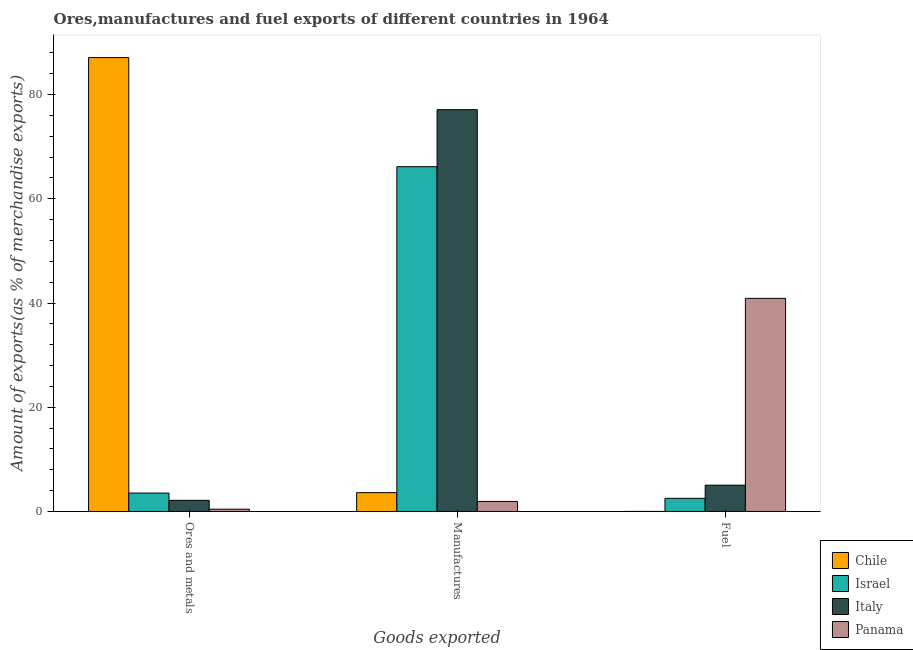How many groups of bars are there?
Your answer should be very brief. 3. Are the number of bars on each tick of the X-axis equal?
Your answer should be very brief. Yes. How many bars are there on the 3rd tick from the left?
Your answer should be compact. 4. What is the label of the 3rd group of bars from the left?
Keep it short and to the point. Fuel. What is the percentage of manufactures exports in Israel?
Provide a short and direct response. 66.16. Across all countries, what is the maximum percentage of manufactures exports?
Provide a succinct answer. 77.1. Across all countries, what is the minimum percentage of fuel exports?
Offer a terse response. 0.01. In which country was the percentage of fuel exports maximum?
Your response must be concise. Panama. In which country was the percentage of manufactures exports minimum?
Make the answer very short. Panama. What is the total percentage of fuel exports in the graph?
Ensure brevity in your answer.  48.48. What is the difference between the percentage of manufactures exports in Italy and that in Israel?
Make the answer very short. 10.94. What is the difference between the percentage of fuel exports in Panama and the percentage of manufactures exports in Italy?
Your answer should be compact. -36.21. What is the average percentage of fuel exports per country?
Ensure brevity in your answer.  12.12. What is the difference between the percentage of manufactures exports and percentage of ores and metals exports in Chile?
Provide a succinct answer. -83.48. In how many countries, is the percentage of ores and metals exports greater than 8 %?
Your answer should be compact. 1. What is the ratio of the percentage of ores and metals exports in Chile to that in Italy?
Offer a very short reply. 40.66. What is the difference between the highest and the second highest percentage of ores and metals exports?
Your answer should be very brief. 83.56. What is the difference between the highest and the lowest percentage of manufactures exports?
Provide a short and direct response. 75.18. In how many countries, is the percentage of ores and metals exports greater than the average percentage of ores and metals exports taken over all countries?
Your response must be concise. 1. Is the sum of the percentage of fuel exports in Italy and Chile greater than the maximum percentage of ores and metals exports across all countries?
Give a very brief answer. No. What does the 3rd bar from the left in Fuel represents?
Provide a short and direct response. Italy. What does the 1st bar from the right in Ores and metals represents?
Offer a very short reply. Panama. How many bars are there?
Your answer should be compact. 12. Are the values on the major ticks of Y-axis written in scientific E-notation?
Offer a terse response. No. Does the graph contain any zero values?
Your answer should be compact. No. Does the graph contain grids?
Give a very brief answer. No. Where does the legend appear in the graph?
Your response must be concise. Bottom right. What is the title of the graph?
Offer a terse response. Ores,manufactures and fuel exports of different countries in 1964. Does "Middle income" appear as one of the legend labels in the graph?
Your answer should be very brief. No. What is the label or title of the X-axis?
Ensure brevity in your answer.  Goods exported. What is the label or title of the Y-axis?
Offer a terse response. Amount of exports(as % of merchandise exports). What is the Amount of exports(as % of merchandise exports) in Chile in Ores and metals?
Your answer should be compact. 87.1. What is the Amount of exports(as % of merchandise exports) in Israel in Ores and metals?
Offer a very short reply. 3.53. What is the Amount of exports(as % of merchandise exports) of Italy in Ores and metals?
Offer a very short reply. 2.14. What is the Amount of exports(as % of merchandise exports) in Panama in Ores and metals?
Provide a short and direct response. 0.44. What is the Amount of exports(as % of merchandise exports) in Chile in Manufactures?
Your answer should be very brief. 3.62. What is the Amount of exports(as % of merchandise exports) in Israel in Manufactures?
Your answer should be compact. 66.16. What is the Amount of exports(as % of merchandise exports) of Italy in Manufactures?
Ensure brevity in your answer.  77.1. What is the Amount of exports(as % of merchandise exports) of Panama in Manufactures?
Provide a succinct answer. 1.93. What is the Amount of exports(as % of merchandise exports) of Chile in Fuel?
Give a very brief answer. 0.01. What is the Amount of exports(as % of merchandise exports) of Israel in Fuel?
Offer a terse response. 2.53. What is the Amount of exports(as % of merchandise exports) of Italy in Fuel?
Offer a terse response. 5.05. What is the Amount of exports(as % of merchandise exports) in Panama in Fuel?
Your answer should be compact. 40.9. Across all Goods exported, what is the maximum Amount of exports(as % of merchandise exports) in Chile?
Provide a short and direct response. 87.1. Across all Goods exported, what is the maximum Amount of exports(as % of merchandise exports) of Israel?
Your answer should be very brief. 66.16. Across all Goods exported, what is the maximum Amount of exports(as % of merchandise exports) of Italy?
Offer a terse response. 77.1. Across all Goods exported, what is the maximum Amount of exports(as % of merchandise exports) of Panama?
Offer a terse response. 40.9. Across all Goods exported, what is the minimum Amount of exports(as % of merchandise exports) of Chile?
Keep it short and to the point. 0.01. Across all Goods exported, what is the minimum Amount of exports(as % of merchandise exports) of Israel?
Keep it short and to the point. 2.53. Across all Goods exported, what is the minimum Amount of exports(as % of merchandise exports) in Italy?
Your answer should be compact. 2.14. Across all Goods exported, what is the minimum Amount of exports(as % of merchandise exports) in Panama?
Your answer should be very brief. 0.44. What is the total Amount of exports(as % of merchandise exports) in Chile in the graph?
Your response must be concise. 90.72. What is the total Amount of exports(as % of merchandise exports) in Israel in the graph?
Your answer should be very brief. 72.22. What is the total Amount of exports(as % of merchandise exports) in Italy in the graph?
Give a very brief answer. 84.3. What is the total Amount of exports(as % of merchandise exports) of Panama in the graph?
Provide a short and direct response. 43.27. What is the difference between the Amount of exports(as % of merchandise exports) in Chile in Ores and metals and that in Manufactures?
Make the answer very short. 83.48. What is the difference between the Amount of exports(as % of merchandise exports) in Israel in Ores and metals and that in Manufactures?
Provide a short and direct response. -62.63. What is the difference between the Amount of exports(as % of merchandise exports) in Italy in Ores and metals and that in Manufactures?
Your answer should be compact. -74.96. What is the difference between the Amount of exports(as % of merchandise exports) of Panama in Ores and metals and that in Manufactures?
Offer a terse response. -1.48. What is the difference between the Amount of exports(as % of merchandise exports) in Chile in Ores and metals and that in Fuel?
Make the answer very short. 87.09. What is the difference between the Amount of exports(as % of merchandise exports) in Israel in Ores and metals and that in Fuel?
Keep it short and to the point. 1.01. What is the difference between the Amount of exports(as % of merchandise exports) of Italy in Ores and metals and that in Fuel?
Offer a very short reply. -2.91. What is the difference between the Amount of exports(as % of merchandise exports) in Panama in Ores and metals and that in Fuel?
Keep it short and to the point. -40.46. What is the difference between the Amount of exports(as % of merchandise exports) of Chile in Manufactures and that in Fuel?
Make the answer very short. 3.61. What is the difference between the Amount of exports(as % of merchandise exports) in Israel in Manufactures and that in Fuel?
Provide a short and direct response. 63.63. What is the difference between the Amount of exports(as % of merchandise exports) in Italy in Manufactures and that in Fuel?
Your answer should be very brief. 72.05. What is the difference between the Amount of exports(as % of merchandise exports) of Panama in Manufactures and that in Fuel?
Offer a terse response. -38.97. What is the difference between the Amount of exports(as % of merchandise exports) in Chile in Ores and metals and the Amount of exports(as % of merchandise exports) in Israel in Manufactures?
Your answer should be compact. 20.94. What is the difference between the Amount of exports(as % of merchandise exports) in Chile in Ores and metals and the Amount of exports(as % of merchandise exports) in Italy in Manufactures?
Provide a succinct answer. 9.99. What is the difference between the Amount of exports(as % of merchandise exports) of Chile in Ores and metals and the Amount of exports(as % of merchandise exports) of Panama in Manufactures?
Keep it short and to the point. 85.17. What is the difference between the Amount of exports(as % of merchandise exports) of Israel in Ores and metals and the Amount of exports(as % of merchandise exports) of Italy in Manufactures?
Offer a very short reply. -73.57. What is the difference between the Amount of exports(as % of merchandise exports) of Israel in Ores and metals and the Amount of exports(as % of merchandise exports) of Panama in Manufactures?
Provide a succinct answer. 1.61. What is the difference between the Amount of exports(as % of merchandise exports) in Italy in Ores and metals and the Amount of exports(as % of merchandise exports) in Panama in Manufactures?
Offer a terse response. 0.22. What is the difference between the Amount of exports(as % of merchandise exports) of Chile in Ores and metals and the Amount of exports(as % of merchandise exports) of Israel in Fuel?
Your response must be concise. 84.57. What is the difference between the Amount of exports(as % of merchandise exports) in Chile in Ores and metals and the Amount of exports(as % of merchandise exports) in Italy in Fuel?
Provide a short and direct response. 82.05. What is the difference between the Amount of exports(as % of merchandise exports) in Chile in Ores and metals and the Amount of exports(as % of merchandise exports) in Panama in Fuel?
Provide a succinct answer. 46.2. What is the difference between the Amount of exports(as % of merchandise exports) of Israel in Ores and metals and the Amount of exports(as % of merchandise exports) of Italy in Fuel?
Provide a succinct answer. -1.52. What is the difference between the Amount of exports(as % of merchandise exports) in Israel in Ores and metals and the Amount of exports(as % of merchandise exports) in Panama in Fuel?
Make the answer very short. -37.36. What is the difference between the Amount of exports(as % of merchandise exports) in Italy in Ores and metals and the Amount of exports(as % of merchandise exports) in Panama in Fuel?
Your answer should be compact. -38.76. What is the difference between the Amount of exports(as % of merchandise exports) in Chile in Manufactures and the Amount of exports(as % of merchandise exports) in Israel in Fuel?
Give a very brief answer. 1.09. What is the difference between the Amount of exports(as % of merchandise exports) of Chile in Manufactures and the Amount of exports(as % of merchandise exports) of Italy in Fuel?
Your answer should be very brief. -1.43. What is the difference between the Amount of exports(as % of merchandise exports) in Chile in Manufactures and the Amount of exports(as % of merchandise exports) in Panama in Fuel?
Your answer should be very brief. -37.28. What is the difference between the Amount of exports(as % of merchandise exports) in Israel in Manufactures and the Amount of exports(as % of merchandise exports) in Italy in Fuel?
Keep it short and to the point. 61.11. What is the difference between the Amount of exports(as % of merchandise exports) in Israel in Manufactures and the Amount of exports(as % of merchandise exports) in Panama in Fuel?
Ensure brevity in your answer.  25.26. What is the difference between the Amount of exports(as % of merchandise exports) in Italy in Manufactures and the Amount of exports(as % of merchandise exports) in Panama in Fuel?
Offer a terse response. 36.21. What is the average Amount of exports(as % of merchandise exports) of Chile per Goods exported?
Provide a succinct answer. 30.24. What is the average Amount of exports(as % of merchandise exports) in Israel per Goods exported?
Provide a succinct answer. 24.07. What is the average Amount of exports(as % of merchandise exports) in Italy per Goods exported?
Ensure brevity in your answer.  28.1. What is the average Amount of exports(as % of merchandise exports) of Panama per Goods exported?
Ensure brevity in your answer.  14.42. What is the difference between the Amount of exports(as % of merchandise exports) of Chile and Amount of exports(as % of merchandise exports) of Israel in Ores and metals?
Make the answer very short. 83.56. What is the difference between the Amount of exports(as % of merchandise exports) in Chile and Amount of exports(as % of merchandise exports) in Italy in Ores and metals?
Your answer should be very brief. 84.96. What is the difference between the Amount of exports(as % of merchandise exports) of Chile and Amount of exports(as % of merchandise exports) of Panama in Ores and metals?
Provide a succinct answer. 86.66. What is the difference between the Amount of exports(as % of merchandise exports) in Israel and Amount of exports(as % of merchandise exports) in Italy in Ores and metals?
Offer a terse response. 1.39. What is the difference between the Amount of exports(as % of merchandise exports) in Israel and Amount of exports(as % of merchandise exports) in Panama in Ores and metals?
Provide a succinct answer. 3.09. What is the difference between the Amount of exports(as % of merchandise exports) of Italy and Amount of exports(as % of merchandise exports) of Panama in Ores and metals?
Your answer should be very brief. 1.7. What is the difference between the Amount of exports(as % of merchandise exports) of Chile and Amount of exports(as % of merchandise exports) of Israel in Manufactures?
Offer a very short reply. -62.54. What is the difference between the Amount of exports(as % of merchandise exports) of Chile and Amount of exports(as % of merchandise exports) of Italy in Manufactures?
Make the answer very short. -73.49. What is the difference between the Amount of exports(as % of merchandise exports) of Chile and Amount of exports(as % of merchandise exports) of Panama in Manufactures?
Make the answer very short. 1.69. What is the difference between the Amount of exports(as % of merchandise exports) of Israel and Amount of exports(as % of merchandise exports) of Italy in Manufactures?
Your answer should be compact. -10.94. What is the difference between the Amount of exports(as % of merchandise exports) in Israel and Amount of exports(as % of merchandise exports) in Panama in Manufactures?
Ensure brevity in your answer.  64.23. What is the difference between the Amount of exports(as % of merchandise exports) of Italy and Amount of exports(as % of merchandise exports) of Panama in Manufactures?
Your answer should be very brief. 75.18. What is the difference between the Amount of exports(as % of merchandise exports) in Chile and Amount of exports(as % of merchandise exports) in Israel in Fuel?
Your response must be concise. -2.52. What is the difference between the Amount of exports(as % of merchandise exports) in Chile and Amount of exports(as % of merchandise exports) in Italy in Fuel?
Make the answer very short. -5.04. What is the difference between the Amount of exports(as % of merchandise exports) in Chile and Amount of exports(as % of merchandise exports) in Panama in Fuel?
Your answer should be compact. -40.89. What is the difference between the Amount of exports(as % of merchandise exports) in Israel and Amount of exports(as % of merchandise exports) in Italy in Fuel?
Ensure brevity in your answer.  -2.53. What is the difference between the Amount of exports(as % of merchandise exports) in Israel and Amount of exports(as % of merchandise exports) in Panama in Fuel?
Your answer should be compact. -38.37. What is the difference between the Amount of exports(as % of merchandise exports) of Italy and Amount of exports(as % of merchandise exports) of Panama in Fuel?
Your answer should be compact. -35.85. What is the ratio of the Amount of exports(as % of merchandise exports) in Chile in Ores and metals to that in Manufactures?
Make the answer very short. 24.07. What is the ratio of the Amount of exports(as % of merchandise exports) of Israel in Ores and metals to that in Manufactures?
Offer a very short reply. 0.05. What is the ratio of the Amount of exports(as % of merchandise exports) in Italy in Ores and metals to that in Manufactures?
Give a very brief answer. 0.03. What is the ratio of the Amount of exports(as % of merchandise exports) of Panama in Ores and metals to that in Manufactures?
Your answer should be very brief. 0.23. What is the ratio of the Amount of exports(as % of merchandise exports) in Chile in Ores and metals to that in Fuel?
Make the answer very short. 9751.01. What is the ratio of the Amount of exports(as % of merchandise exports) in Israel in Ores and metals to that in Fuel?
Your response must be concise. 1.4. What is the ratio of the Amount of exports(as % of merchandise exports) of Italy in Ores and metals to that in Fuel?
Give a very brief answer. 0.42. What is the ratio of the Amount of exports(as % of merchandise exports) in Panama in Ores and metals to that in Fuel?
Provide a short and direct response. 0.01. What is the ratio of the Amount of exports(as % of merchandise exports) of Chile in Manufactures to that in Fuel?
Provide a succinct answer. 405.03. What is the ratio of the Amount of exports(as % of merchandise exports) of Israel in Manufactures to that in Fuel?
Your response must be concise. 26.19. What is the ratio of the Amount of exports(as % of merchandise exports) of Italy in Manufactures to that in Fuel?
Keep it short and to the point. 15.26. What is the ratio of the Amount of exports(as % of merchandise exports) of Panama in Manufactures to that in Fuel?
Keep it short and to the point. 0.05. What is the difference between the highest and the second highest Amount of exports(as % of merchandise exports) in Chile?
Keep it short and to the point. 83.48. What is the difference between the highest and the second highest Amount of exports(as % of merchandise exports) of Israel?
Provide a succinct answer. 62.63. What is the difference between the highest and the second highest Amount of exports(as % of merchandise exports) in Italy?
Offer a terse response. 72.05. What is the difference between the highest and the second highest Amount of exports(as % of merchandise exports) in Panama?
Keep it short and to the point. 38.97. What is the difference between the highest and the lowest Amount of exports(as % of merchandise exports) of Chile?
Provide a succinct answer. 87.09. What is the difference between the highest and the lowest Amount of exports(as % of merchandise exports) in Israel?
Offer a terse response. 63.63. What is the difference between the highest and the lowest Amount of exports(as % of merchandise exports) of Italy?
Make the answer very short. 74.96. What is the difference between the highest and the lowest Amount of exports(as % of merchandise exports) in Panama?
Your answer should be compact. 40.46. 